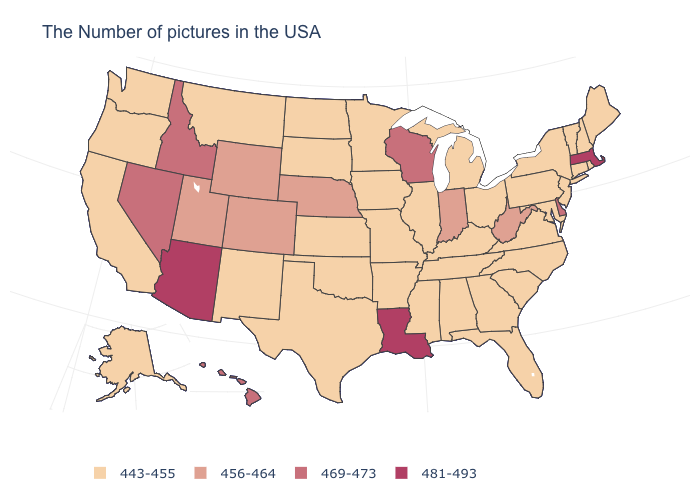Is the legend a continuous bar?
Short answer required. No. Name the states that have a value in the range 456-464?
Quick response, please. West Virginia, Indiana, Nebraska, Wyoming, Colorado, Utah. What is the lowest value in the USA?
Quick response, please. 443-455. What is the value of Connecticut?
Answer briefly. 443-455. Which states have the lowest value in the USA?
Quick response, please. Maine, Rhode Island, New Hampshire, Vermont, Connecticut, New York, New Jersey, Maryland, Pennsylvania, Virginia, North Carolina, South Carolina, Ohio, Florida, Georgia, Michigan, Kentucky, Alabama, Tennessee, Illinois, Mississippi, Missouri, Arkansas, Minnesota, Iowa, Kansas, Oklahoma, Texas, South Dakota, North Dakota, New Mexico, Montana, California, Washington, Oregon, Alaska. Name the states that have a value in the range 443-455?
Answer briefly. Maine, Rhode Island, New Hampshire, Vermont, Connecticut, New York, New Jersey, Maryland, Pennsylvania, Virginia, North Carolina, South Carolina, Ohio, Florida, Georgia, Michigan, Kentucky, Alabama, Tennessee, Illinois, Mississippi, Missouri, Arkansas, Minnesota, Iowa, Kansas, Oklahoma, Texas, South Dakota, North Dakota, New Mexico, Montana, California, Washington, Oregon, Alaska. Does Maine have the lowest value in the USA?
Quick response, please. Yes. Does North Dakota have the lowest value in the MidWest?
Keep it brief. Yes. What is the highest value in states that border Georgia?
Be succinct. 443-455. What is the value of Wisconsin?
Keep it brief. 469-473. Does South Carolina have the lowest value in the USA?
Keep it brief. Yes. Does Colorado have the lowest value in the West?
Be succinct. No. Name the states that have a value in the range 456-464?
Answer briefly. West Virginia, Indiana, Nebraska, Wyoming, Colorado, Utah. 